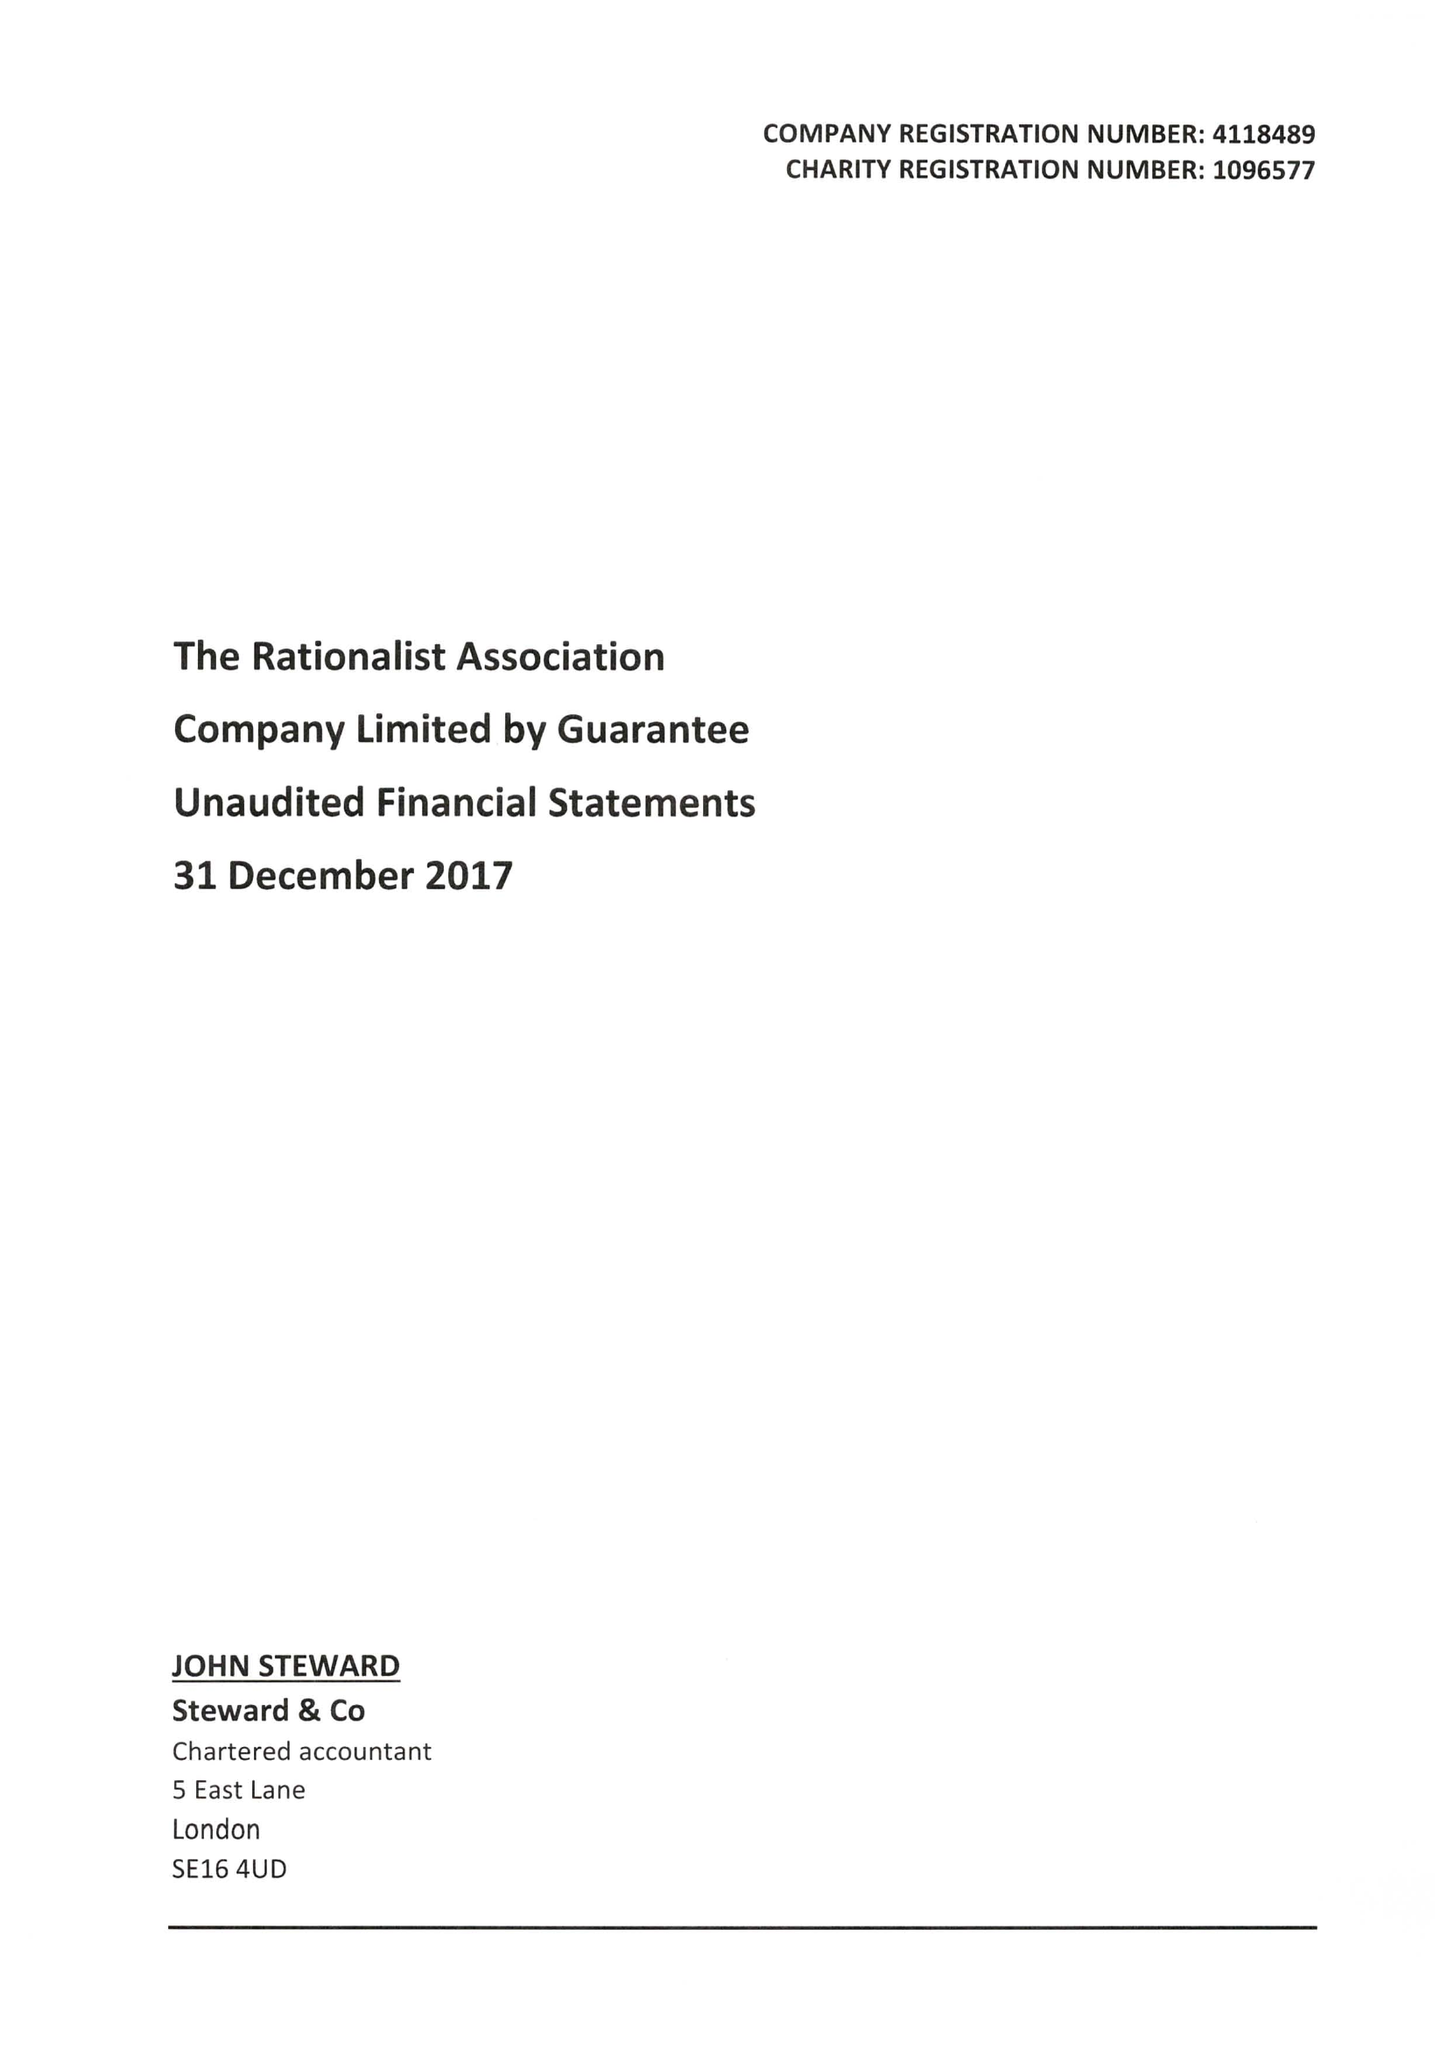What is the value for the income_annually_in_british_pounds?
Answer the question using a single word or phrase. 151219.00 